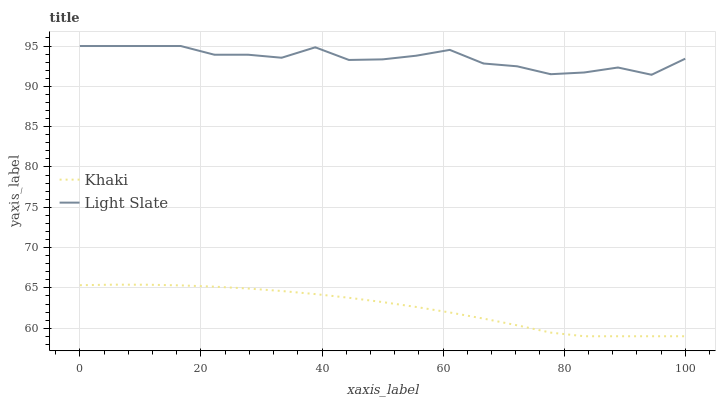Does Khaki have the minimum area under the curve?
Answer yes or no. Yes. Does Light Slate have the maximum area under the curve?
Answer yes or no. Yes. Does Khaki have the maximum area under the curve?
Answer yes or no. No. Is Khaki the smoothest?
Answer yes or no. Yes. Is Light Slate the roughest?
Answer yes or no. Yes. Is Khaki the roughest?
Answer yes or no. No. Does Khaki have the highest value?
Answer yes or no. No. Is Khaki less than Light Slate?
Answer yes or no. Yes. Is Light Slate greater than Khaki?
Answer yes or no. Yes. Does Khaki intersect Light Slate?
Answer yes or no. No. 